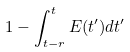Convert formula to latex. <formula><loc_0><loc_0><loc_500><loc_500>1 - \int _ { t - r } ^ { t } E ( t ^ { \prime } ) d t ^ { \prime }</formula> 